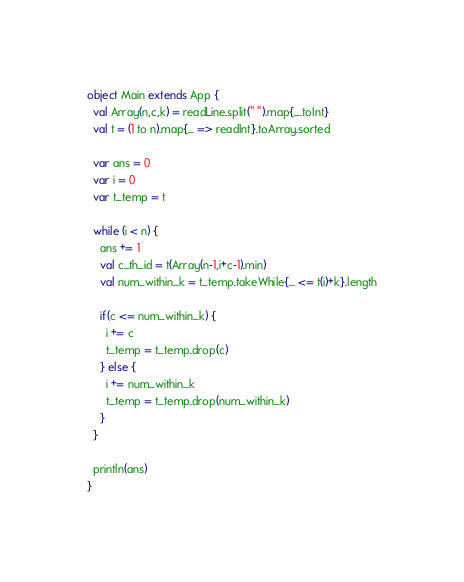Convert code to text. <code><loc_0><loc_0><loc_500><loc_500><_Scala_>object Main extends App {
  val Array(n,c,k) = readLine.split(" ").map{_.toInt}
  val t = (1 to n).map{_ => readInt}.toArray.sorted
  
  var ans = 0
  var i = 0
  var t_temp = t
  
  while (i < n) {
    ans += 1
    val c_th_id = t(Array(n-1,i+c-1).min)
    val num_within_k = t_temp.takeWhile{_ <= t(i)+k}.length
    
    if(c <= num_within_k) {
      i += c
      t_temp = t_temp.drop(c)
    } else {
      i += num_within_k
      t_temp = t_temp.drop(num_within_k)
    }
  }
  
  println(ans)
}</code> 